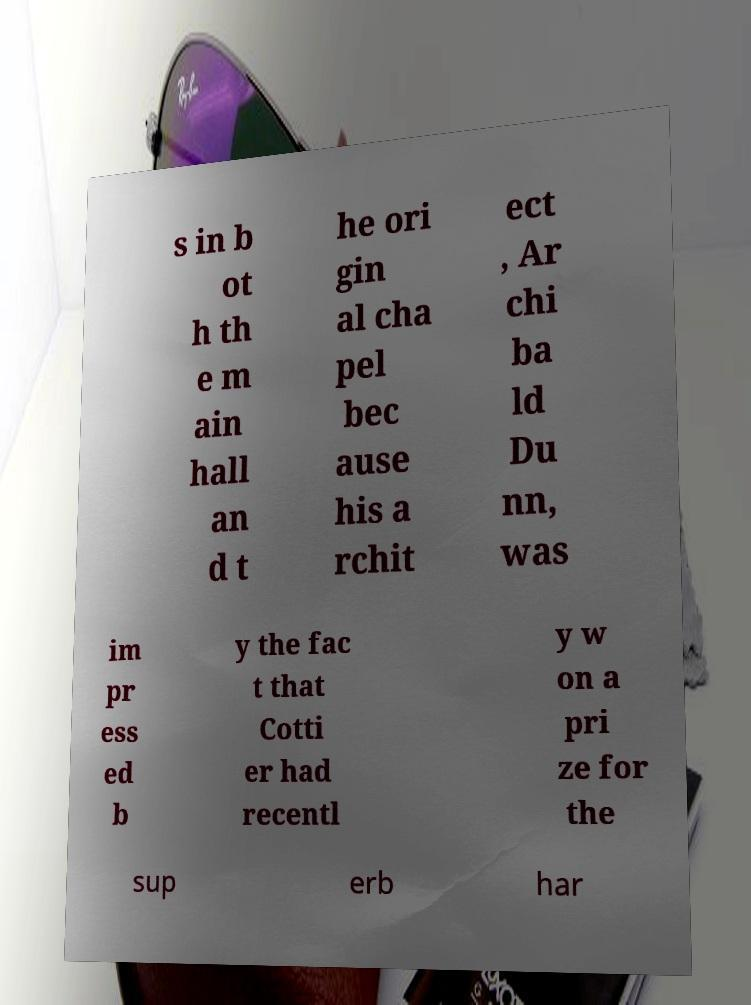What messages or text are displayed in this image? I need them in a readable, typed format. s in b ot h th e m ain hall an d t he ori gin al cha pel bec ause his a rchit ect , Ar chi ba ld Du nn, was im pr ess ed b y the fac t that Cotti er had recentl y w on a pri ze for the sup erb har 